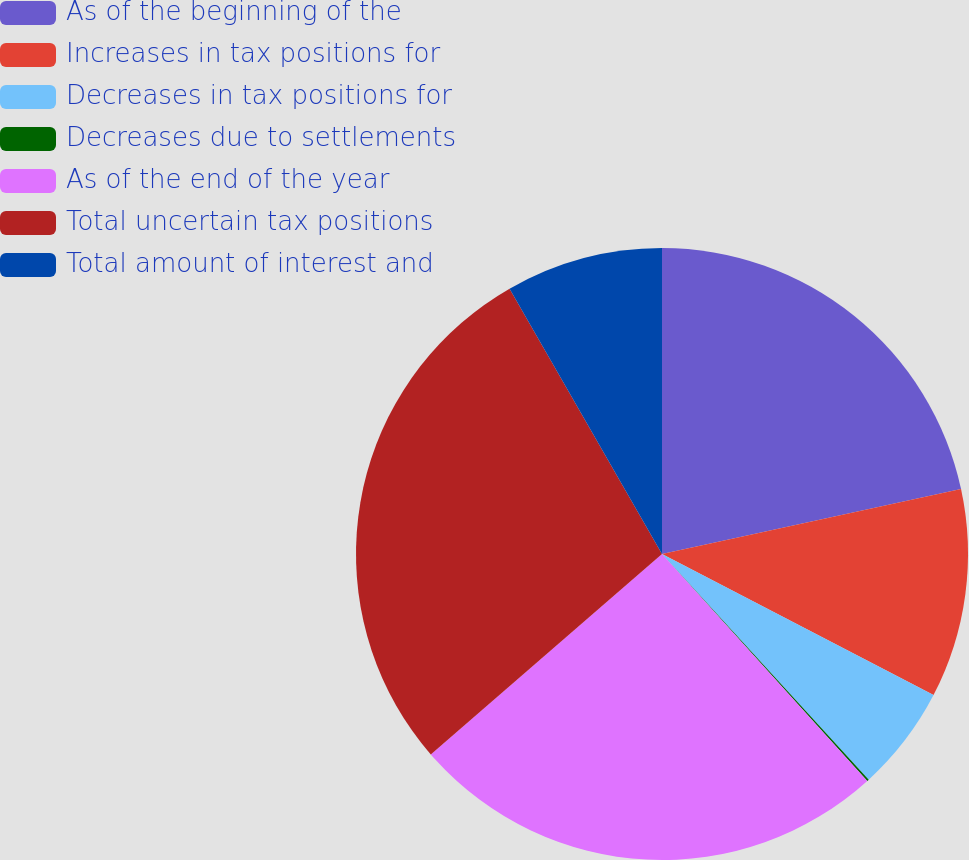<chart> <loc_0><loc_0><loc_500><loc_500><pie_chart><fcel>As of the beginning of the<fcel>Increases in tax positions for<fcel>Decreases in tax positions for<fcel>Decreases due to settlements<fcel>As of the end of the year<fcel>Total uncertain tax positions<fcel>Total amount of interest and<nl><fcel>21.6%<fcel>11.03%<fcel>5.57%<fcel>0.1%<fcel>25.34%<fcel>28.07%<fcel>8.3%<nl></chart> 